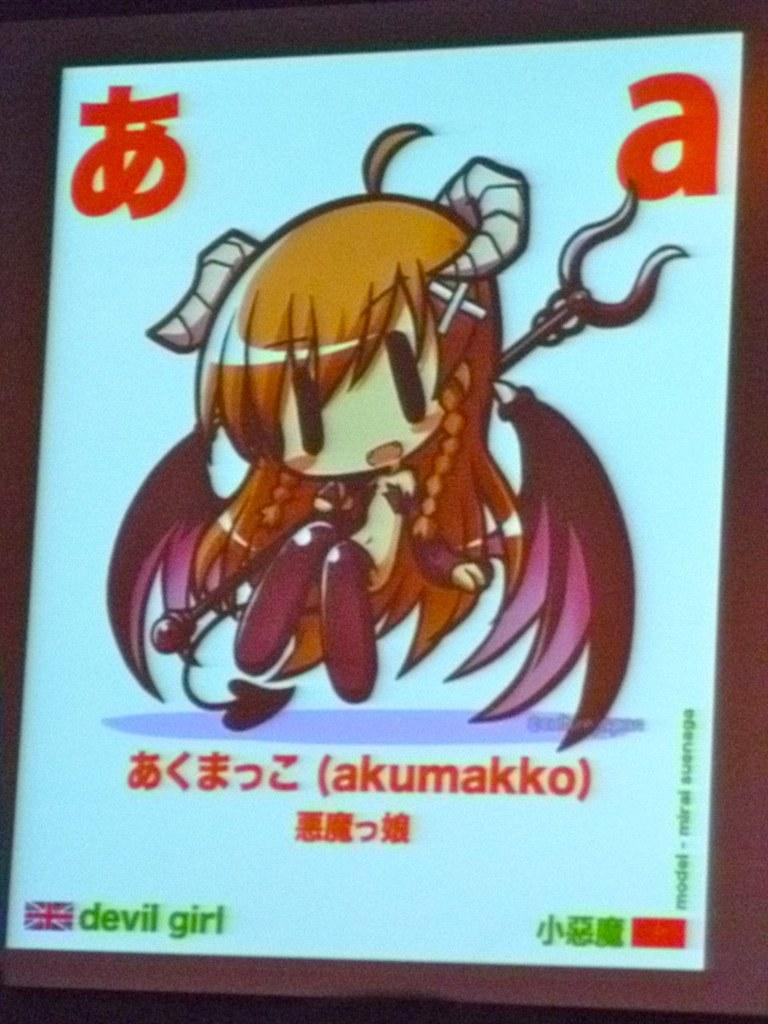Provide a one-sentence caption for the provided image. The letter a is prominently displayed in the upper right hand corner of the screen, above the cartoon girl. 